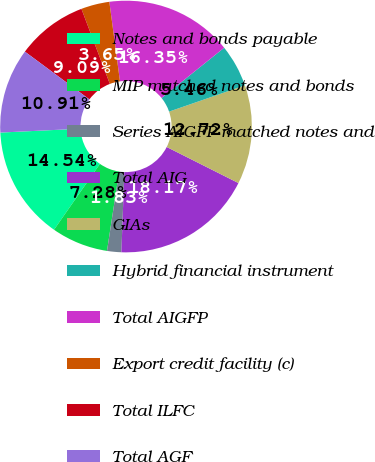<chart> <loc_0><loc_0><loc_500><loc_500><pie_chart><fcel>Notes and bonds payable<fcel>MIP matched notes and bonds<fcel>Series AIGFP matched notes and<fcel>Total AIG<fcel>GIAs<fcel>Hybrid financial instrument<fcel>Total AIGFP<fcel>Export credit facility (c)<fcel>Total ILFC<fcel>Total AGF<nl><fcel>14.54%<fcel>7.28%<fcel>1.83%<fcel>18.17%<fcel>12.72%<fcel>5.46%<fcel>16.35%<fcel>3.65%<fcel>9.09%<fcel>10.91%<nl></chart> 